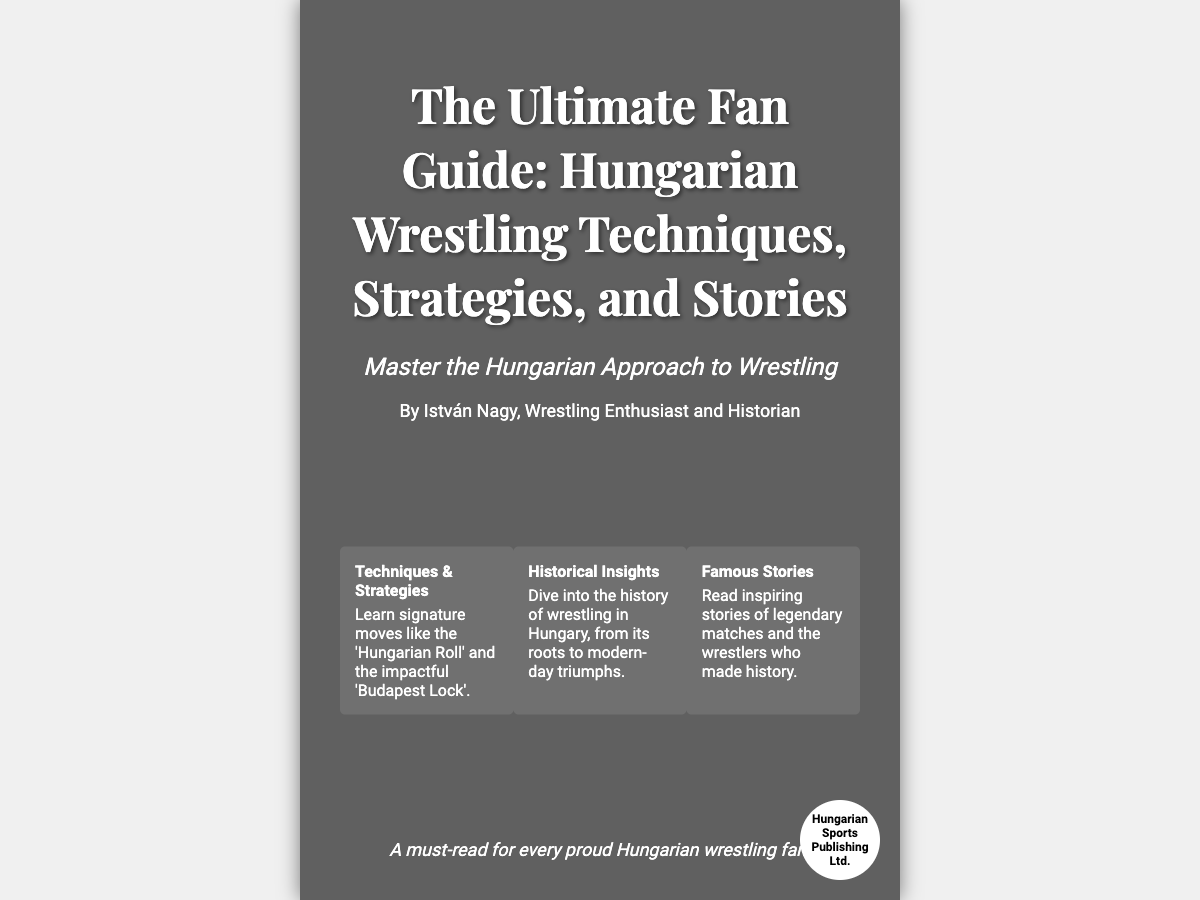What is the title of the book? The title of the book is prominently displayed at the top of the cover.
Answer: The Ultimate Fan Guide: Hungarian Wrestling Techniques, Strategies, and Stories Who is the author of the book? The author's name is mentioned below the title on the cover.
Answer: István Nagy What is the tagline of the book? The tagline provides a brief insight into the book’s focus and is located under the title.
Answer: Master the Hungarian Approach to Wrestling What are the three main features highlighted on the cover? The features are specifically listed in boxes on the cover, each focusing on different aspects of the book.
Answer: Techniques & Strategies, Historical Insights, Famous Stories What is the publisher's name? The publisher's name is displayed in the logo at the bottom right of the cover.
Answer: Hungarian Sports Publishing Ltd What signature move is mentioned in the Techniques & Strategies feature? The feature box includes specific techniques that are significant in Hungarian wrestling.
Answer: Hungarian Roll How does the author describe their involvement with wrestling? The author is identified by a phrase that characterizes their passion and knowledge in wrestling.
Answer: Wrestling Enthusiast and Historian What is the intended audience for the book as stated in the footer? The footer contains a statement that identifies the target audience of the book.
Answer: Every proud Hungarian wrestling fan 